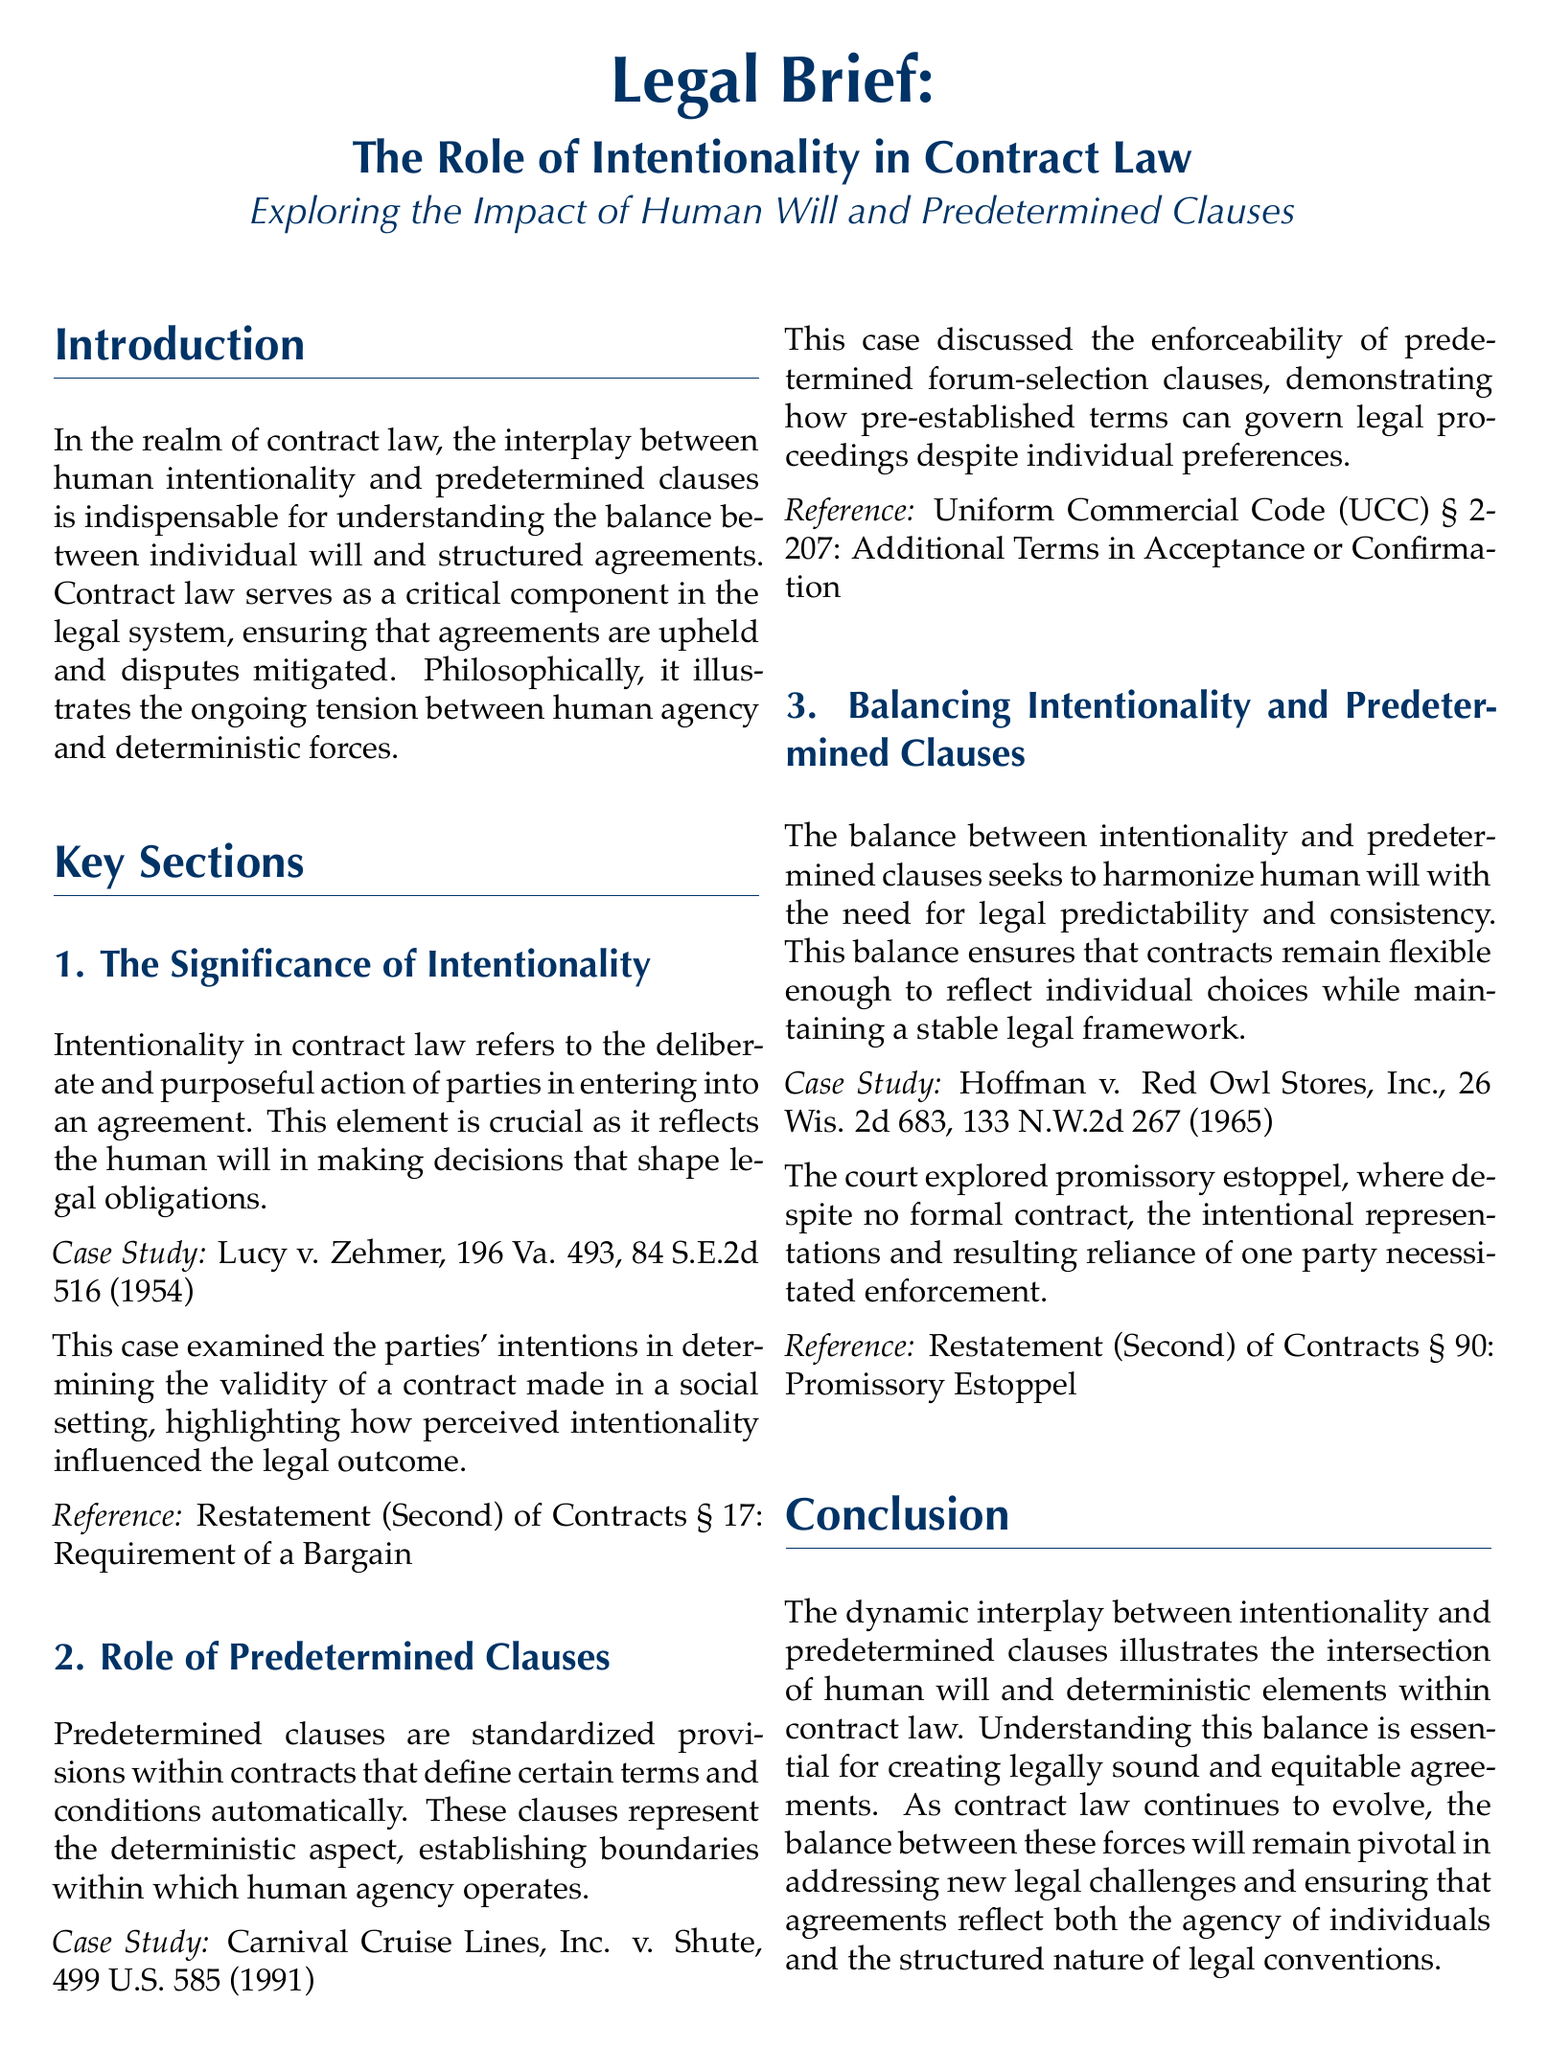what is the title of the document? The title provides the main subject of the legal brief focusing on intentionality in contract law.
Answer: The Role of Intentionality in Contract Law who are the parties involved in the case study Lucy v. Zehmer? The case study highlights the intention of the parties involved in evaluating contract validity.
Answer: Lucy and Zehmer what year was the case Lucy v. Zehmer decided? The year provides a historical context for the legal case referenced in the brief.
Answer: 1954 what is the primary subject explored in this legal brief? The subject of the brief revolves around the concepts of human will and predetermined clauses in the context of contract law.
Answer: Intentionality which clause is discussed in the case study Carnival Cruise Lines, Inc. v. Shute? This question pertains to understanding the specific legal provision examined in the case study.
Answer: forum-selection clauses what legal concept is highlighted in Hoffman v. Red Owl Stores, Inc.? The concept relates to the enforcement of promises in the absence of a formal contract, showcasing the balance of intentionality.
Answer: promissory estoppel what is the reference provided for the requirement of a bargain? This reference is critical for understanding the foundational principles in contract law mentioned in the brief.
Answer: Restatement (Second) of Contracts § 17 how does the document describe the relationship between human will and legal structure? The description elaborates on the interaction between individual choices and the predictability of legal systems.
Answer: balancing what section refers to additional terms in acceptance? This identifies the specific legal regulation relevant to contract acceptance in the brief.
Answer: Uniform Commercial Code (UCC) § 2-207 